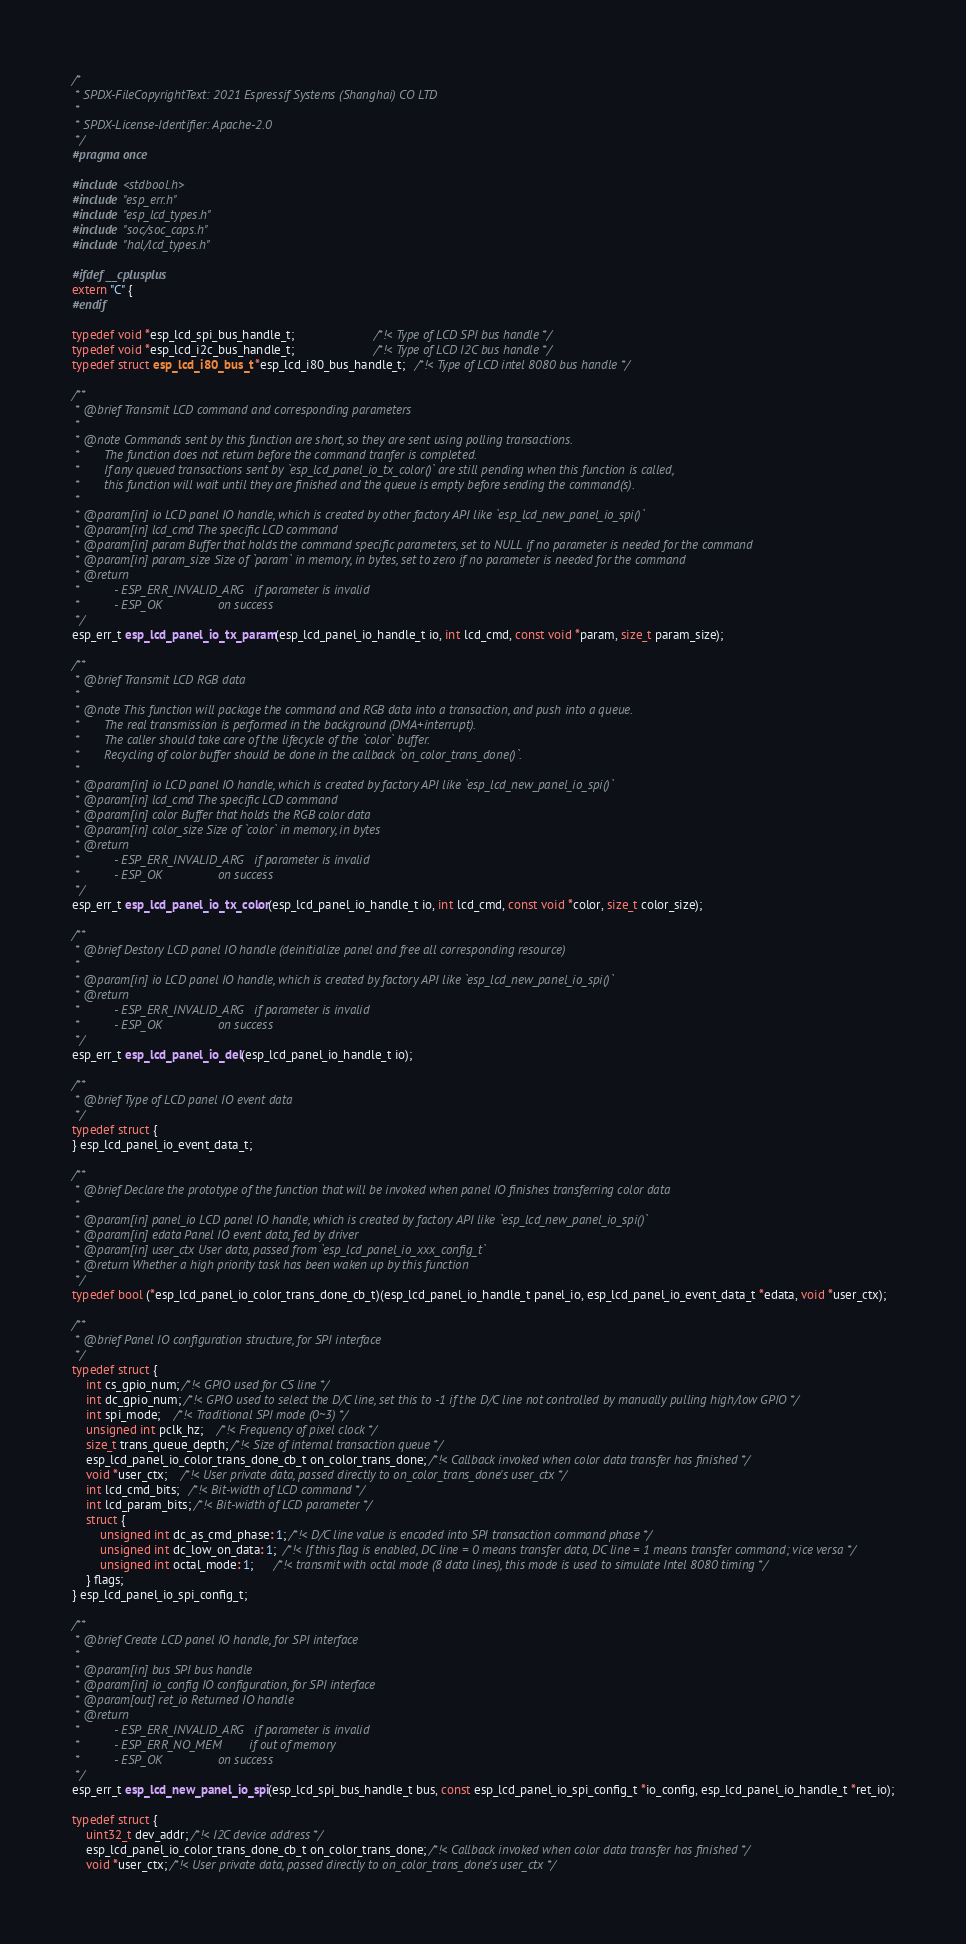<code> <loc_0><loc_0><loc_500><loc_500><_C_>/*
 * SPDX-FileCopyrightText: 2021 Espressif Systems (Shanghai) CO LTD
 *
 * SPDX-License-Identifier: Apache-2.0
 */
#pragma once

#include <stdbool.h>
#include "esp_err.h"
#include "esp_lcd_types.h"
#include "soc/soc_caps.h"
#include "hal/lcd_types.h"

#ifdef __cplusplus
extern "C" {
#endif

typedef void *esp_lcd_spi_bus_handle_t;                       /*!< Type of LCD SPI bus handle */
typedef void *esp_lcd_i2c_bus_handle_t;                       /*!< Type of LCD I2C bus handle */
typedef struct esp_lcd_i80_bus_t *esp_lcd_i80_bus_handle_t;   /*!< Type of LCD intel 8080 bus handle */

/**
 * @brief Transmit LCD command and corresponding parameters
 *
 * @note Commands sent by this function are short, so they are sent using polling transactions.
 *       The function does not return before the command tranfer is completed.
 *       If any queued transactions sent by `esp_lcd_panel_io_tx_color()` are still pending when this function is called,
 *       this function will wait until they are finished and the queue is empty before sending the command(s).
 *
 * @param[in] io LCD panel IO handle, which is created by other factory API like `esp_lcd_new_panel_io_spi()`
 * @param[in] lcd_cmd The specific LCD command
 * @param[in] param Buffer that holds the command specific parameters, set to NULL if no parameter is needed for the command
 * @param[in] param_size Size of `param` in memory, in bytes, set to zero if no parameter is needed for the command
 * @return
 *          - ESP_ERR_INVALID_ARG   if parameter is invalid
 *          - ESP_OK                on success
 */
esp_err_t esp_lcd_panel_io_tx_param(esp_lcd_panel_io_handle_t io, int lcd_cmd, const void *param, size_t param_size);

/**
 * @brief Transmit LCD RGB data
 *
 * @note This function will package the command and RGB data into a transaction, and push into a queue.
 *       The real transmission is performed in the background (DMA+interrupt).
 *       The caller should take care of the lifecycle of the `color` buffer.
 *       Recycling of color buffer should be done in the callback `on_color_trans_done()`.
 *
 * @param[in] io LCD panel IO handle, which is created by factory API like `esp_lcd_new_panel_io_spi()`
 * @param[in] lcd_cmd The specific LCD command
 * @param[in] color Buffer that holds the RGB color data
 * @param[in] color_size Size of `color` in memory, in bytes
 * @return
 *          - ESP_ERR_INVALID_ARG   if parameter is invalid
 *          - ESP_OK                on success
 */
esp_err_t esp_lcd_panel_io_tx_color(esp_lcd_panel_io_handle_t io, int lcd_cmd, const void *color, size_t color_size);

/**
 * @brief Destory LCD panel IO handle (deinitialize panel and free all corresponding resource)
 *
 * @param[in] io LCD panel IO handle, which is created by factory API like `esp_lcd_new_panel_io_spi()`
 * @return
 *          - ESP_ERR_INVALID_ARG   if parameter is invalid
 *          - ESP_OK                on success
 */
esp_err_t esp_lcd_panel_io_del(esp_lcd_panel_io_handle_t io);

/**
 * @brief Type of LCD panel IO event data
 */
typedef struct {
} esp_lcd_panel_io_event_data_t;

/**
 * @brief Declare the prototype of the function that will be invoked when panel IO finishes transferring color data
 *
 * @param[in] panel_io LCD panel IO handle, which is created by factory API like `esp_lcd_new_panel_io_spi()`
 * @param[in] edata Panel IO event data, fed by driver
 * @param[in] user_ctx User data, passed from `esp_lcd_panel_io_xxx_config_t`
 * @return Whether a high priority task has been waken up by this function
 */
typedef bool (*esp_lcd_panel_io_color_trans_done_cb_t)(esp_lcd_panel_io_handle_t panel_io, esp_lcd_panel_io_event_data_t *edata, void *user_ctx);

/**
 * @brief Panel IO configuration structure, for SPI interface
 */
typedef struct {
    int cs_gpio_num; /*!< GPIO used for CS line */
    int dc_gpio_num; /*!< GPIO used to select the D/C line, set this to -1 if the D/C line not controlled by manually pulling high/low GPIO */
    int spi_mode;    /*!< Traditional SPI mode (0~3) */
    unsigned int pclk_hz;    /*!< Frequency of pixel clock */
    size_t trans_queue_depth; /*!< Size of internal transaction queue */
    esp_lcd_panel_io_color_trans_done_cb_t on_color_trans_done; /*!< Callback invoked when color data transfer has finished */
    void *user_ctx;    /*!< User private data, passed directly to on_color_trans_done's user_ctx */
    int lcd_cmd_bits;   /*!< Bit-width of LCD command */
    int lcd_param_bits; /*!< Bit-width of LCD parameter */
    struct {
        unsigned int dc_as_cmd_phase: 1; /*!< D/C line value is encoded into SPI transaction command phase */
        unsigned int dc_low_on_data: 1;  /*!< If this flag is enabled, DC line = 0 means transfer data, DC line = 1 means transfer command; vice versa */
        unsigned int octal_mode: 1;      /*!< transmit with octal mode (8 data lines), this mode is used to simulate Intel 8080 timing */
    } flags;
} esp_lcd_panel_io_spi_config_t;

/**
 * @brief Create LCD panel IO handle, for SPI interface
 *
 * @param[in] bus SPI bus handle
 * @param[in] io_config IO configuration, for SPI interface
 * @param[out] ret_io Returned IO handle
 * @return
 *          - ESP_ERR_INVALID_ARG   if parameter is invalid
 *          - ESP_ERR_NO_MEM        if out of memory
 *          - ESP_OK                on success
 */
esp_err_t esp_lcd_new_panel_io_spi(esp_lcd_spi_bus_handle_t bus, const esp_lcd_panel_io_spi_config_t *io_config, esp_lcd_panel_io_handle_t *ret_io);

typedef struct {
    uint32_t dev_addr; /*!< I2C device address */
    esp_lcd_panel_io_color_trans_done_cb_t on_color_trans_done; /*!< Callback invoked when color data transfer has finished */
    void *user_ctx; /*!< User private data, passed directly to on_color_trans_done's user_ctx */</code> 